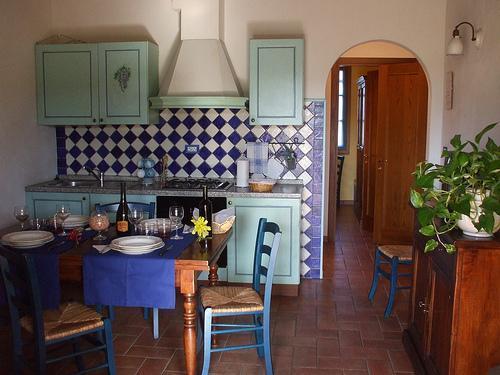How many bottles are on the table?
Give a very brief answer. 2. 